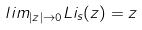Convert formula to latex. <formula><loc_0><loc_0><loc_500><loc_500>l i m _ { | z | \rightarrow 0 } L i _ { s } ( z ) = z</formula> 